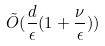<formula> <loc_0><loc_0><loc_500><loc_500>\tilde { O } ( \frac { d } { \epsilon } ( 1 + \frac { \nu } { \epsilon } ) )</formula> 